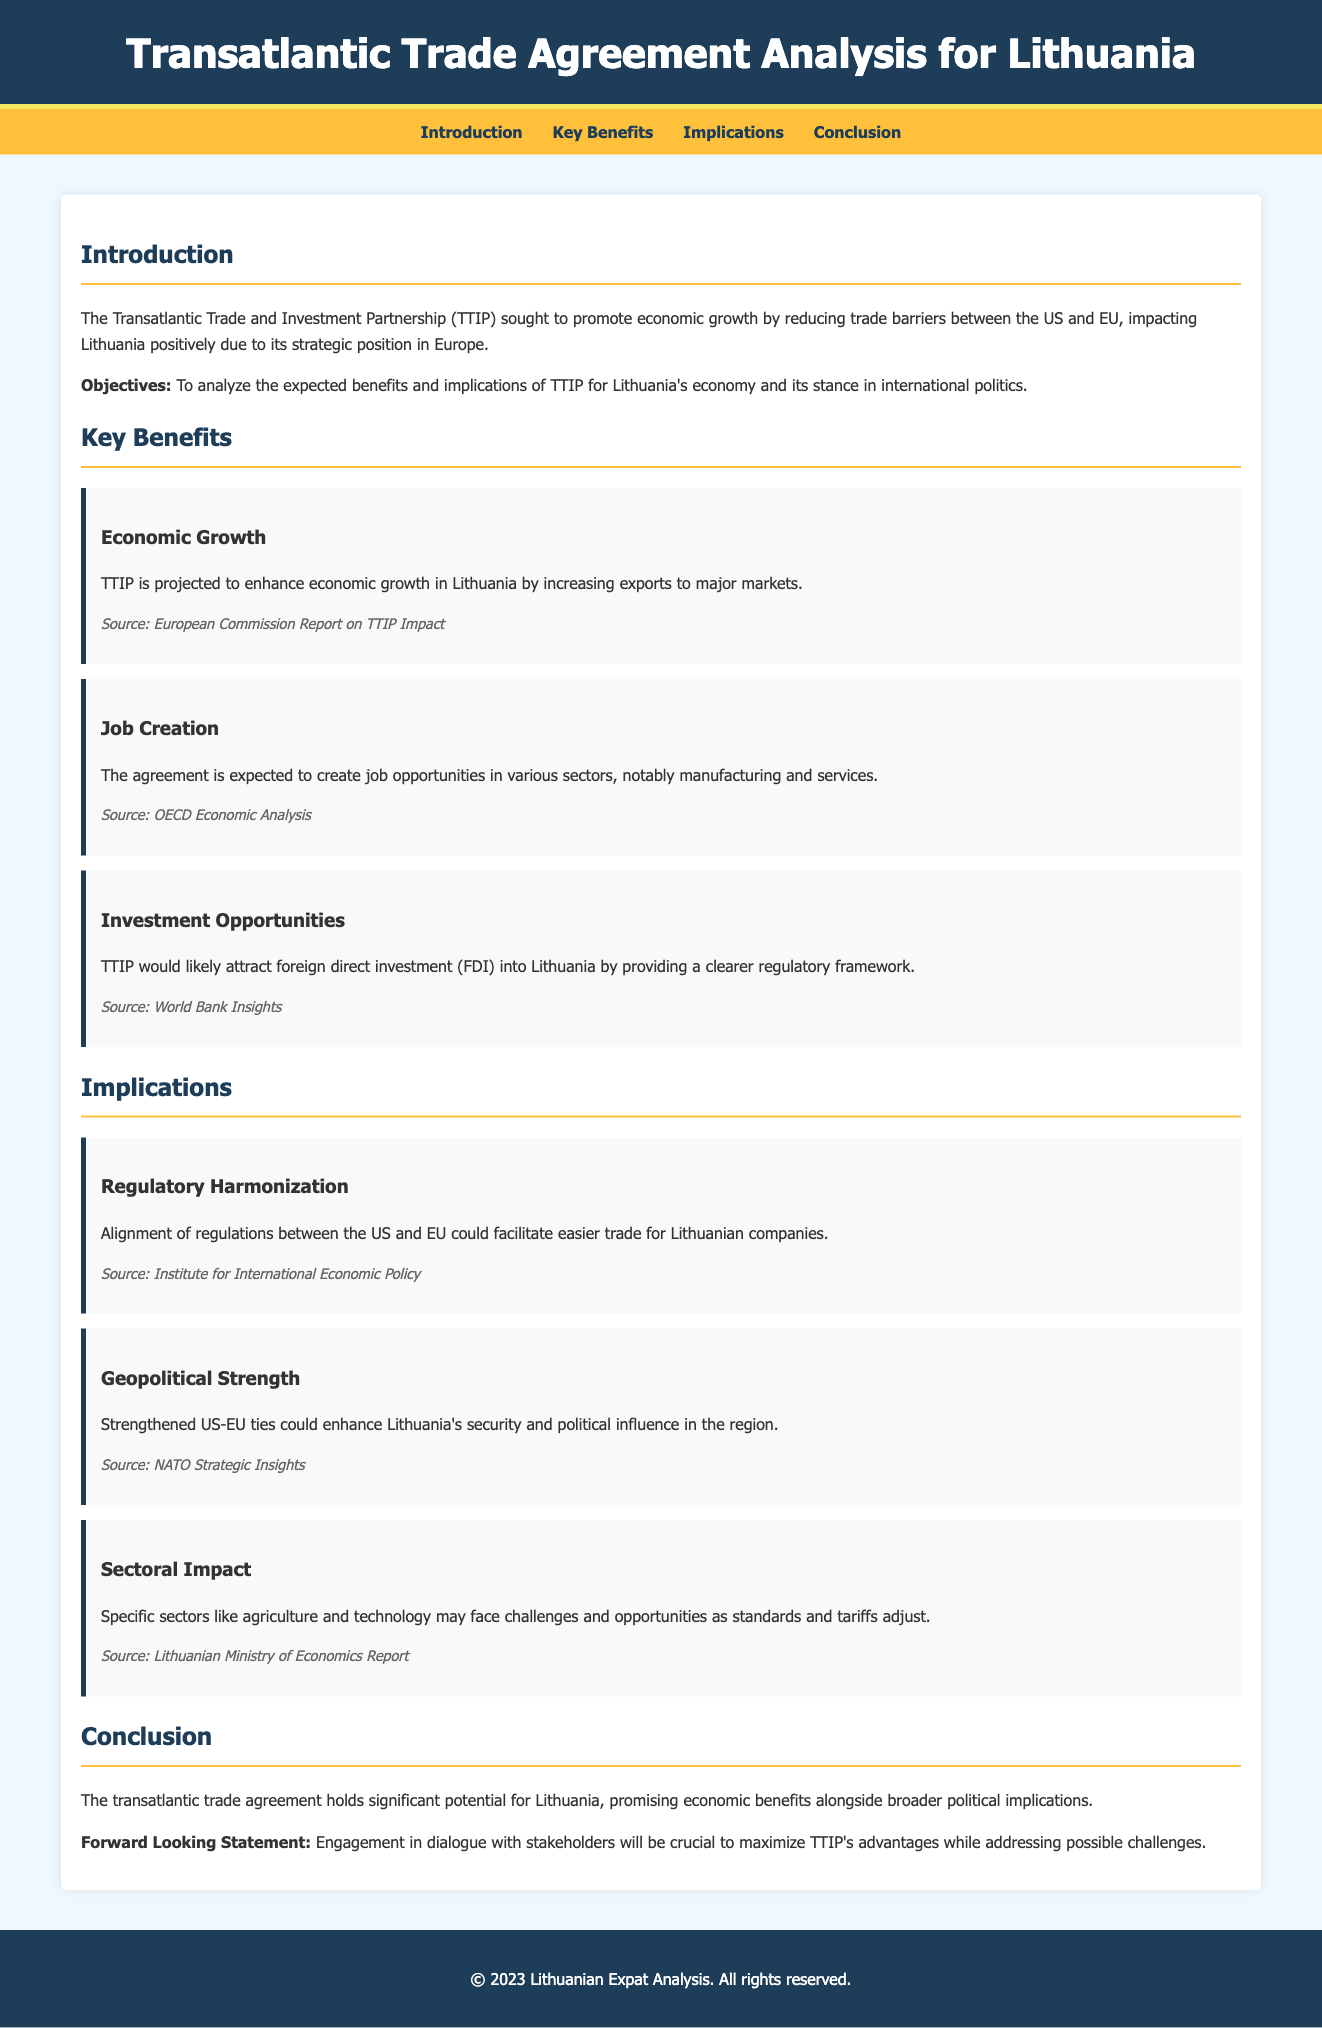What is the title of the document? The title of the document appears at the top of the header section.
Answer: Transatlantic Trade Agreement Analysis for Lithuania What is one of the objectives of the analysis? The objectives are listed in the introduction section of the document.
Answer: To analyze the expected benefits and implications of TTIP for Lithuania's economy and its stance in international politics How many key benefits are listed in the document? The document outlines three key benefits under the "Key Benefits" section.
Answer: Three What sector is expected to create job opportunities? The document mentions specific sectors in the "Key Benefits" section that will be positively impacted by TTIP.
Answer: Manufacturing and services What is a potential implication for Lithuanian companies mentioned? The document discusses how regulatory changes could affect trade for Lithuanian companies in the "Implications" section.
Answer: Regulatory Harmonization Which two geographical entities’ ties are strengthened by the agreement? The geopolitical aspect mentioned in the implications section highlights these two entities.
Answer: US and EU What will be crucial for maximizing TTIP's advantages? The conclusion section emphasizes the importance of engaging with specific groups to optimize benefits.
Answer: Engagement in dialogue with stakeholders 